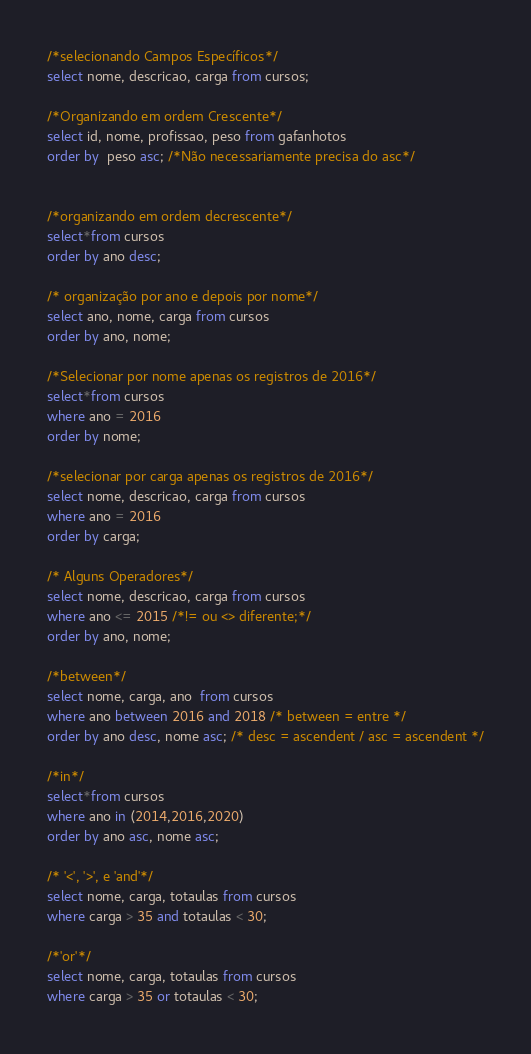Convert code to text. <code><loc_0><loc_0><loc_500><loc_500><_SQL_>/*selecionando Campos Específicos*/
select nome, descricao, carga from cursos;

/*Organizando em ordem Crescente*/
select id, nome, profissao, peso from gafanhotos
order by  peso asc; /*Não necessariamente precisa do asc*/


/*organizando em ordem decrescente*/
select*from cursos
order by ano desc;

/* organização por ano e depois por nome*/
select ano, nome, carga from cursos
order by ano, nome;

/*Selecionar por nome apenas os registros de 2016*/
select*from cursos
where ano = 2016
order by nome;

/*selecionar por carga apenas os registros de 2016*/
select nome, descricao, carga from cursos
where ano = 2016
order by carga;

/* Alguns Operadores*/
select nome, descricao, carga from cursos
where ano <= 2015 /*!= ou <> diferente;*/ 
order by ano, nome;

/*between*/
select nome, carga, ano  from cursos
where ano between 2016 and 2018 /* between = entre */
order by ano desc, nome asc; /* desc = ascendent / asc = ascendent */

/*in*/
select*from cursos
where ano in (2014,2016,2020)
order by ano asc, nome asc;

/* '<', '>', e 'and'*/
select nome, carga, totaulas from cursos
where carga > 35 and totaulas < 30;

/*'or'*/
select nome, carga, totaulas from cursos
where carga > 35 or totaulas < 30;
</code> 